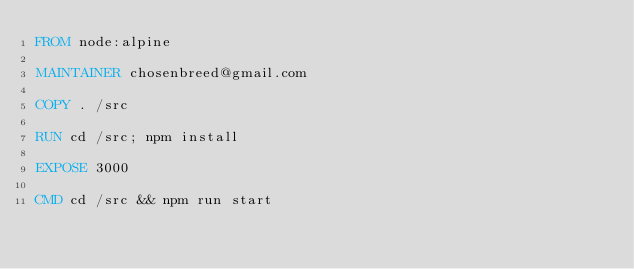Convert code to text. <code><loc_0><loc_0><loc_500><loc_500><_Dockerfile_>FROM node:alpine

MAINTAINER chosenbreed@gmail.com

COPY . /src

RUN cd /src; npm install

EXPOSE 3000

CMD cd /src && npm run start</code> 